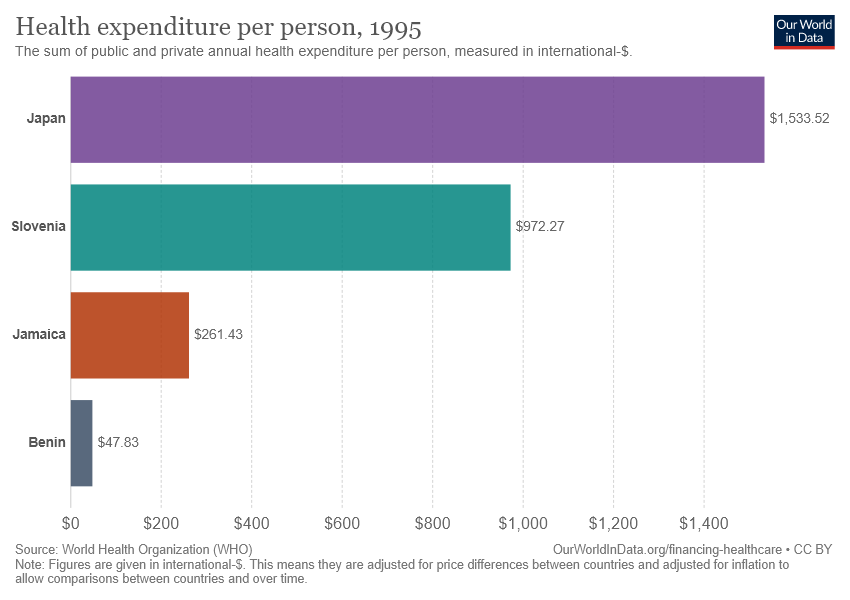Highlight a few significant elements in this photo. The total annual health expenditure per person in Slovenia, both public and private, is approximately $972.27. The median of all the bars is 616.85. 